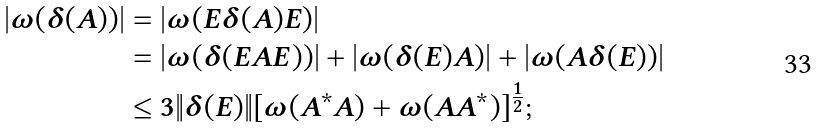<formula> <loc_0><loc_0><loc_500><loc_500>| \omega ( \delta ( A ) ) | & = | \omega ( E \delta ( A ) E ) | \\ & = | \omega ( \delta ( E A E ) ) | + | \omega ( \delta ( E ) A ) | + | \omega ( A \delta ( E ) ) | \\ & \leq 3 \| \delta ( E ) \| [ \omega ( A ^ { * } A ) + \omega ( A A ^ { * } ) ] ^ { \frac { 1 } { 2 } } ;</formula> 